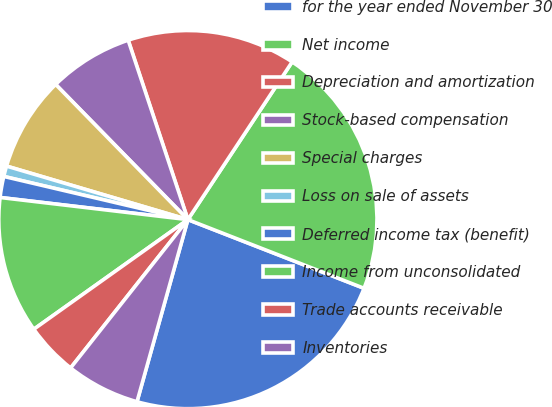Convert chart to OTSL. <chart><loc_0><loc_0><loc_500><loc_500><pie_chart><fcel>for the year ended November 30<fcel>Net income<fcel>Depreciation and amortization<fcel>Stock-based compensation<fcel>Special charges<fcel>Loss on sale of assets<fcel>Deferred income tax (benefit)<fcel>Income from unconsolidated<fcel>Trade accounts receivable<fcel>Inventories<nl><fcel>23.42%<fcel>21.62%<fcel>14.41%<fcel>7.21%<fcel>8.11%<fcel>0.9%<fcel>1.8%<fcel>11.71%<fcel>4.51%<fcel>6.31%<nl></chart> 